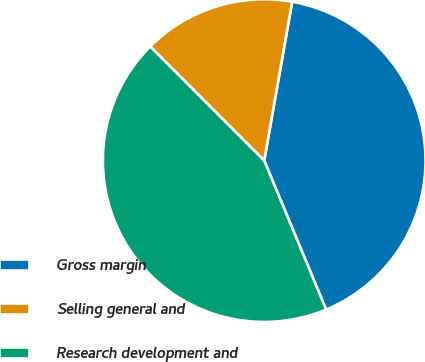<chart> <loc_0><loc_0><loc_500><loc_500><pie_chart><fcel>Gross margin<fcel>Selling general and<fcel>Research development and<nl><fcel>40.96%<fcel>15.26%<fcel>43.78%<nl></chart> 